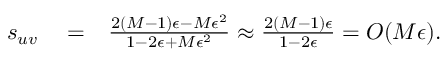Convert formula to latex. <formula><loc_0><loc_0><loc_500><loc_500>\begin{array} { r l r } { s _ { u v } } & = } & { \frac { 2 ( M - 1 ) \epsilon - M \epsilon ^ { 2 } } { 1 - 2 \epsilon + M \epsilon ^ { 2 } } \approx \frac { 2 ( M - 1 ) \epsilon } { 1 - 2 \epsilon } = O ( M \epsilon ) . } \end{array}</formula> 